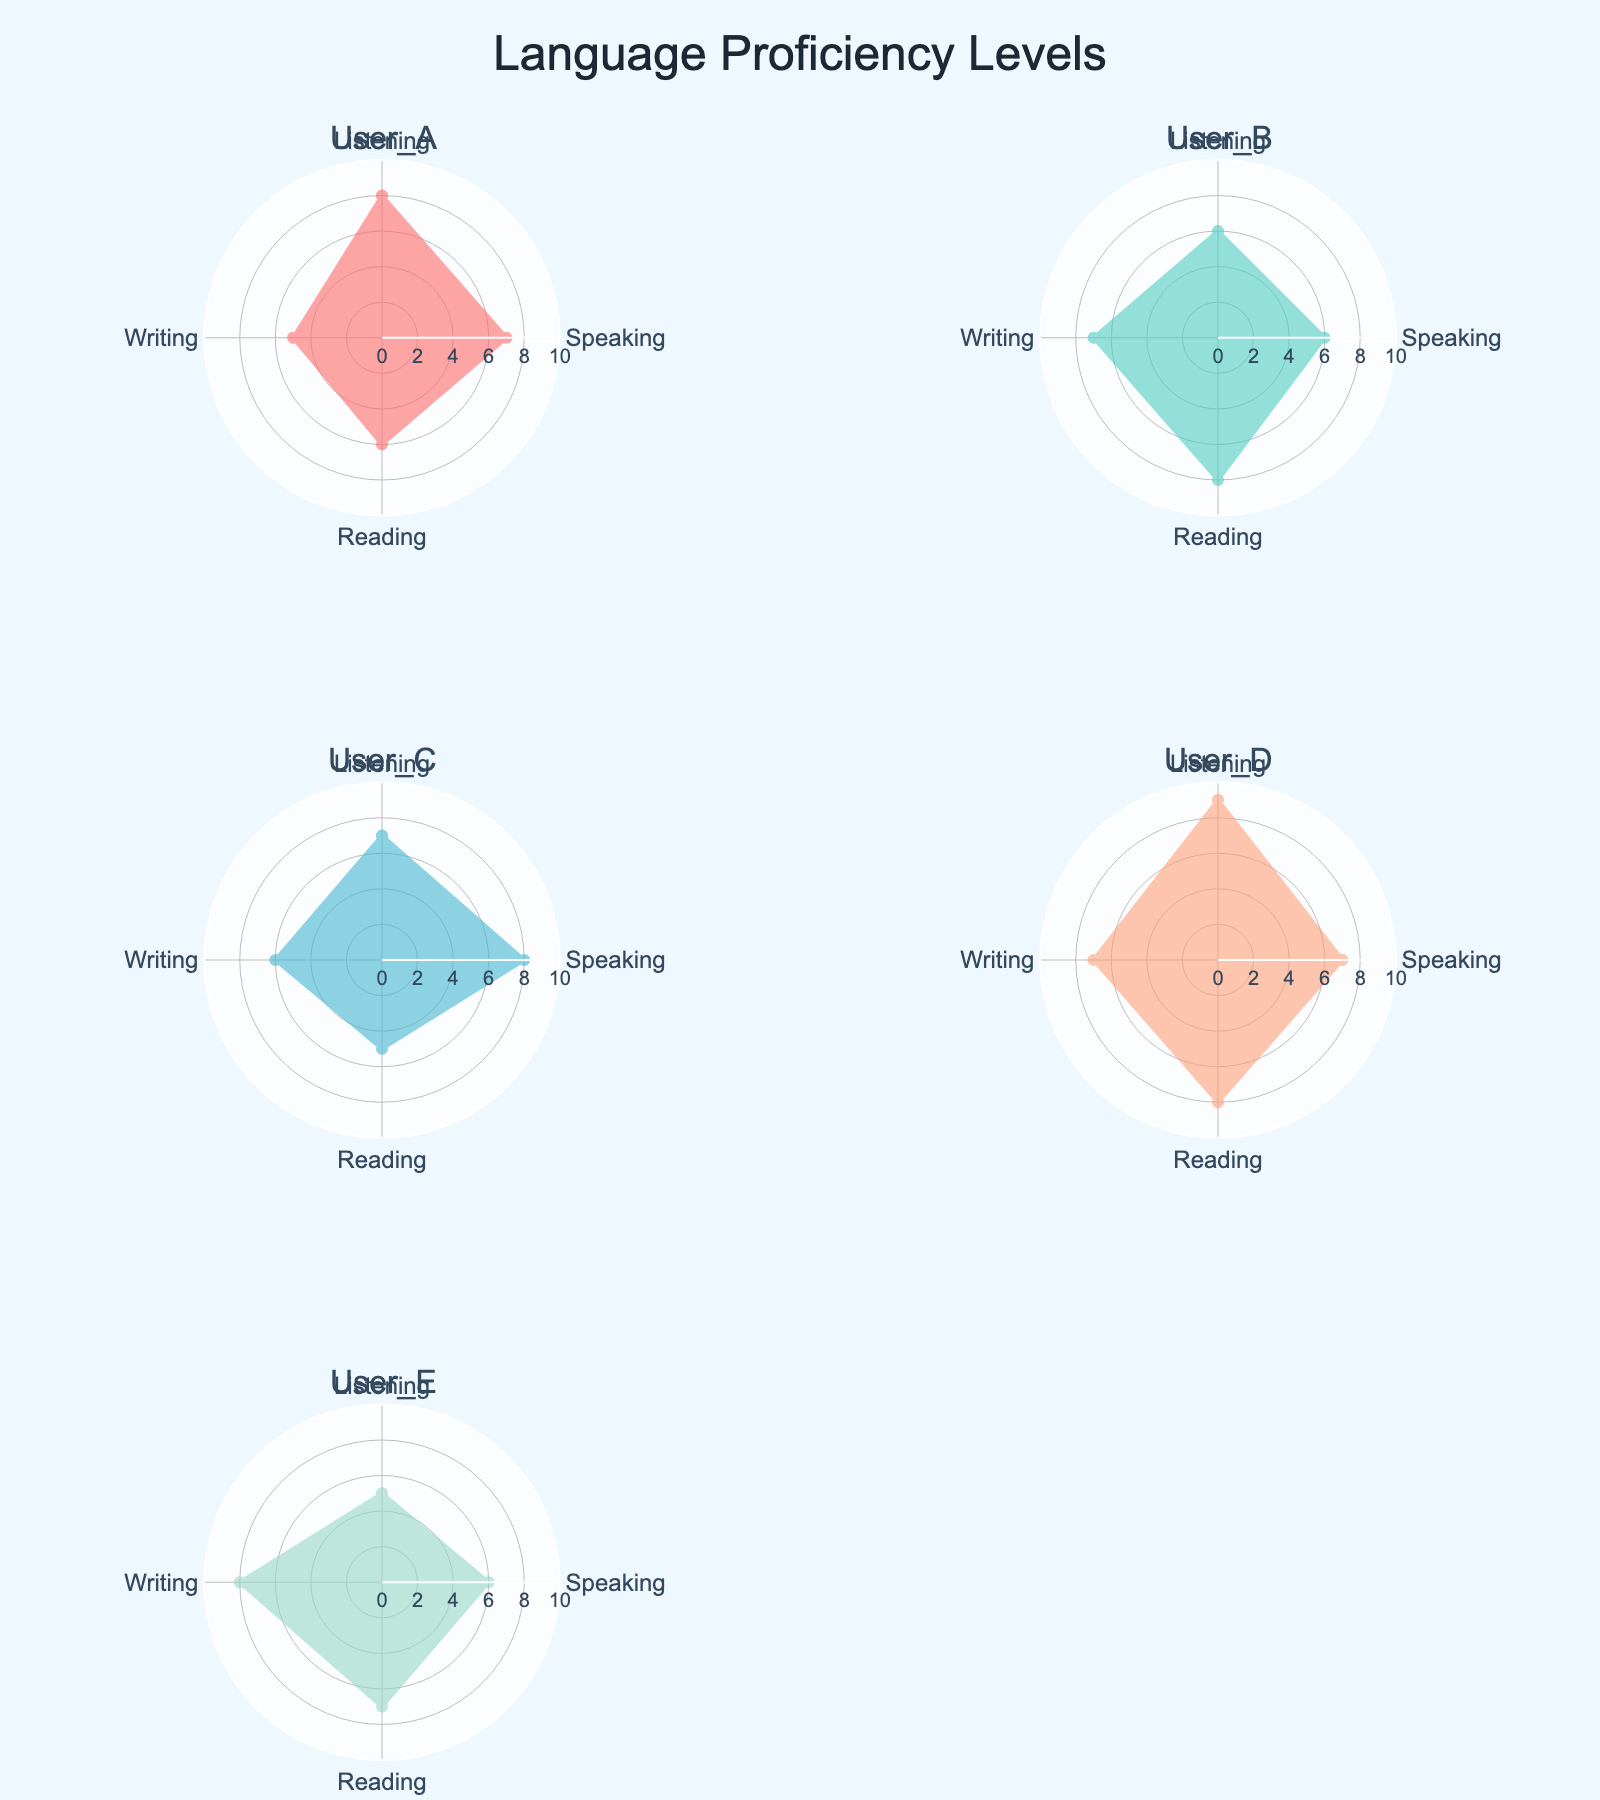Who has the highest proficiency in Listening? Look at each subplot, which represents individual users' proficiency levels across different skills. Compare the values for Listening. User_D has the highest Listening level at 9.
Answer: User_D What is the average Reading proficiency level across all users? Identify the Reading proficiency values for each user: 6, 8, 5, 8, and 7. Sum these values: 6 + 8 + 5 + 8 + 7 = 34. There are 5 users, so divide the sum by 5 to find the average: 34 / 5 = 6.8.
Answer: 6.8 Which skill does User_E have the highest proficiency in? Examine User_E's subplot and find the maximum proficiency value. The values are 5 (Listening), 6 (Speaking), 7 (Reading), and 8 (Writing). The highest value is 8 in Writing.
Answer: Writing Are there any users with identical Speaking and Writing proficiency levels? Compare the Speaking and Writing values for each user: User_A (7, 5), User_B (6, 7), User_C (8, 6), User_D (7, 7), and User_E (6, 8). Only User_D has identical Speaking and Writing values of 7.
Answer: Yes, User_D Who has the largest difference between Listening and Writing proficiency? Calculate the difference between Listening and Writing for each user: User_A: 8 - 5 = 3, User_B: 6 - 7 = 1, User_C: 7 - 6 = 1, User_D: 9 - 7 = 2, User_E: 5 - 8 = -3. The largest absolute difference is 3 for User_A.
Answer: User_A Which user has the highest overall proficiency (sum of all skills)? Sum the proficiency levels for each user: User_A: 8 + 7 + 6 + 5 = 26, User_B: 6 + 6 + 8 + 7 = 27, User_C: 7 + 8 + 5 + 6 = 26, User_D: 9 + 7 + 8 + 7 = 31, User_E: 5 + 6 + 7 + 8 = 26. The highest sum is 31 for User_D.
Answer: User_D Between User_B and User_E, who is better at Reading? Compare the Reading proficiency values of User_B (8) and User_E (7). User_B has a higher value.
Answer: User_B Which user shows the most balanced proficiency across all skills (smallest range between highest and lowest)? Calculate the range (max - min) for each user: User_A: 8 - 5 = 3, User_B: 8 - 6 = 2, User_C: 8 - 5 = 3, User_D: 9 - 7 = 2, User_E: 8 - 5 = 3. Both User_B and User_D have the smallest range of 2.
Answer: User_B and User_D What is the total proficiency in Writing for all users combined? Add the Writing proficiency levels for each user: 5 + 7 + 6 + 7 + 8 = 33.
Answer: 33 